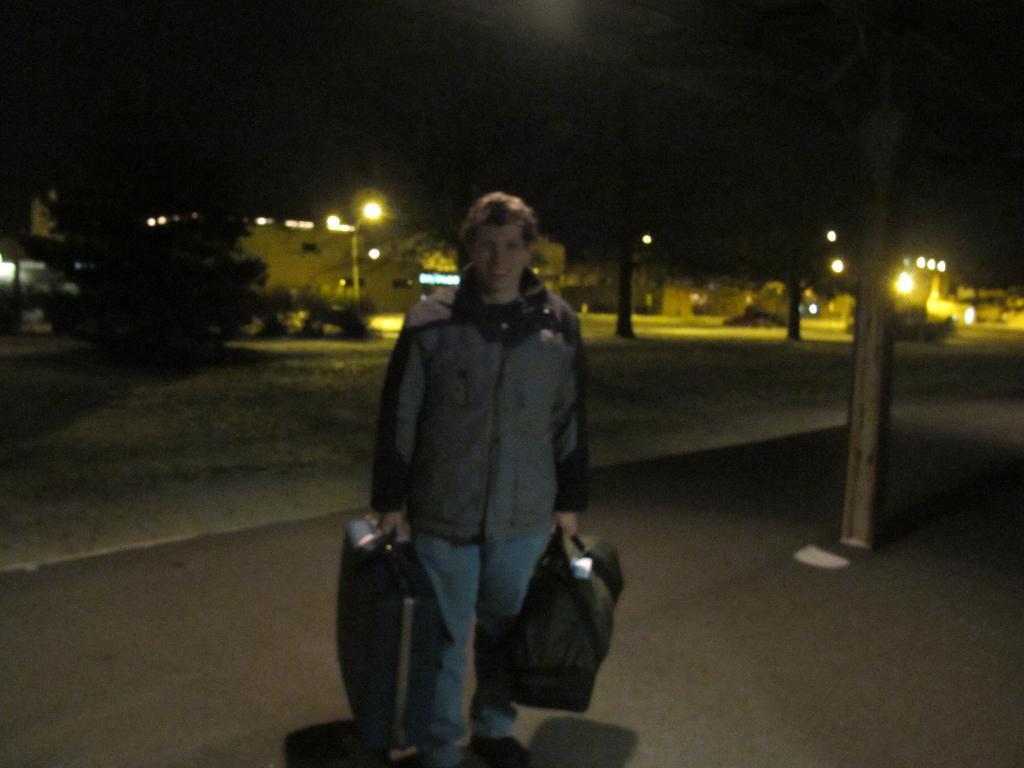Describe this image in one or two sentences. In the image we can see a person standing, wearing clothes and holding luggage bags. Here we can see the road, poles, tree, lights and the dark sky. 